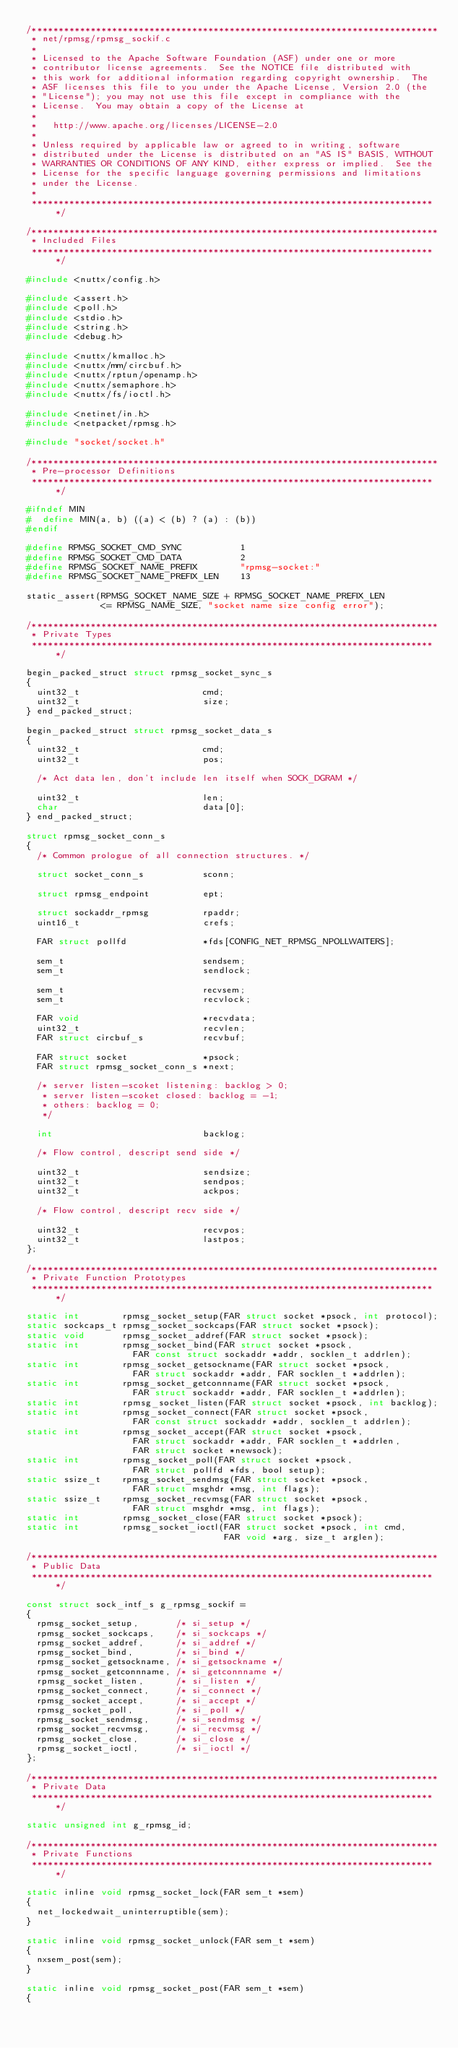Convert code to text. <code><loc_0><loc_0><loc_500><loc_500><_C_>/****************************************************************************
 * net/rpmsg/rpmsg_sockif.c
 *
 * Licensed to the Apache Software Foundation (ASF) under one or more
 * contributor license agreements.  See the NOTICE file distributed with
 * this work for additional information regarding copyright ownership.  The
 * ASF licenses this file to you under the Apache License, Version 2.0 (the
 * "License"); you may not use this file except in compliance with the
 * License.  You may obtain a copy of the License at
 *
 *   http://www.apache.org/licenses/LICENSE-2.0
 *
 * Unless required by applicable law or agreed to in writing, software
 * distributed under the License is distributed on an "AS IS" BASIS, WITHOUT
 * WARRANTIES OR CONDITIONS OF ANY KIND, either express or implied.  See the
 * License for the specific language governing permissions and limitations
 * under the License.
 *
 ****************************************************************************/

/****************************************************************************
 * Included Files
 ****************************************************************************/

#include <nuttx/config.h>

#include <assert.h>
#include <poll.h>
#include <stdio.h>
#include <string.h>
#include <debug.h>

#include <nuttx/kmalloc.h>
#include <nuttx/mm/circbuf.h>
#include <nuttx/rptun/openamp.h>
#include <nuttx/semaphore.h>
#include <nuttx/fs/ioctl.h>

#include <netinet/in.h>
#include <netpacket/rpmsg.h>

#include "socket/socket.h"

/****************************************************************************
 * Pre-processor Definitions
 ****************************************************************************/

#ifndef MIN
#  define MIN(a, b) ((a) < (b) ? (a) : (b))
#endif

#define RPMSG_SOCKET_CMD_SYNC           1
#define RPMSG_SOCKET_CMD_DATA           2
#define RPMSG_SOCKET_NAME_PREFIX        "rpmsg-socket:"
#define RPMSG_SOCKET_NAME_PREFIX_LEN    13

static_assert(RPMSG_SOCKET_NAME_SIZE + RPMSG_SOCKET_NAME_PREFIX_LEN
              <= RPMSG_NAME_SIZE, "socket name size config error");

/****************************************************************************
 * Private Types
 ****************************************************************************/

begin_packed_struct struct rpmsg_socket_sync_s
{
  uint32_t                       cmd;
  uint32_t                       size;
} end_packed_struct;

begin_packed_struct struct rpmsg_socket_data_s
{
  uint32_t                       cmd;
  uint32_t                       pos;

  /* Act data len, don't include len itself when SOCK_DGRAM */

  uint32_t                       len;
  char                           data[0];
} end_packed_struct;

struct rpmsg_socket_conn_s
{
  /* Common prologue of all connection structures. */

  struct socket_conn_s           sconn;

  struct rpmsg_endpoint          ept;

  struct sockaddr_rpmsg          rpaddr;
  uint16_t                       crefs;

  FAR struct pollfd              *fds[CONFIG_NET_RPMSG_NPOLLWAITERS];

  sem_t                          sendsem;
  sem_t                          sendlock;

  sem_t                          recvsem;
  sem_t                          recvlock;

  FAR void                       *recvdata;
  uint32_t                       recvlen;
  FAR struct circbuf_s           recvbuf;

  FAR struct socket              *psock;
  FAR struct rpmsg_socket_conn_s *next;

  /* server listen-scoket listening: backlog > 0;
   * server listen-scoket closed: backlog = -1;
   * others: backlog = 0;
   */

  int                            backlog;

  /* Flow control, descript send side */

  uint32_t                       sendsize;
  uint32_t                       sendpos;
  uint32_t                       ackpos;

  /* Flow control, descript recv side */

  uint32_t                       recvpos;
  uint32_t                       lastpos;
};

/****************************************************************************
 * Private Function Prototypes
 ****************************************************************************/

static int        rpmsg_socket_setup(FAR struct socket *psock, int protocol);
static sockcaps_t rpmsg_socket_sockcaps(FAR struct socket *psock);
static void       rpmsg_socket_addref(FAR struct socket *psock);
static int        rpmsg_socket_bind(FAR struct socket *psock,
                    FAR const struct sockaddr *addr, socklen_t addrlen);
static int        rpmsg_socket_getsockname(FAR struct socket *psock,
                    FAR struct sockaddr *addr, FAR socklen_t *addrlen);
static int        rpmsg_socket_getconnname(FAR struct socket *psock,
                    FAR struct sockaddr *addr, FAR socklen_t *addrlen);
static int        rpmsg_socket_listen(FAR struct socket *psock, int backlog);
static int        rpmsg_socket_connect(FAR struct socket *psock,
                    FAR const struct sockaddr *addr, socklen_t addrlen);
static int        rpmsg_socket_accept(FAR struct socket *psock,
                    FAR struct sockaddr *addr, FAR socklen_t *addrlen,
                    FAR struct socket *newsock);
static int        rpmsg_socket_poll(FAR struct socket *psock,
                    FAR struct pollfd *fds, bool setup);
static ssize_t    rpmsg_socket_sendmsg(FAR struct socket *psock,
                    FAR struct msghdr *msg, int flags);
static ssize_t    rpmsg_socket_recvmsg(FAR struct socket *psock,
                    FAR struct msghdr *msg, int flags);
static int        rpmsg_socket_close(FAR struct socket *psock);
static int        rpmsg_socket_ioctl(FAR struct socket *psock, int cmd,
                                     FAR void *arg, size_t arglen);

/****************************************************************************
 * Public Data
 ****************************************************************************/

const struct sock_intf_s g_rpmsg_sockif =
{
  rpmsg_socket_setup,       /* si_setup */
  rpmsg_socket_sockcaps,    /* si_sockcaps */
  rpmsg_socket_addref,      /* si_addref */
  rpmsg_socket_bind,        /* si_bind */
  rpmsg_socket_getsockname, /* si_getsockname */
  rpmsg_socket_getconnname, /* si_getconnname */
  rpmsg_socket_listen,      /* si_listen */
  rpmsg_socket_connect,     /* si_connect */
  rpmsg_socket_accept,      /* si_accept */
  rpmsg_socket_poll,        /* si_poll */
  rpmsg_socket_sendmsg,     /* si_sendmsg */
  rpmsg_socket_recvmsg,     /* si_recvmsg */
  rpmsg_socket_close,       /* si_close */
  rpmsg_socket_ioctl,       /* si_ioctl */
};

/****************************************************************************
 * Private Data
 ****************************************************************************/

static unsigned int g_rpmsg_id;

/****************************************************************************
 * Private Functions
 ****************************************************************************/

static inline void rpmsg_socket_lock(FAR sem_t *sem)
{
  net_lockedwait_uninterruptible(sem);
}

static inline void rpmsg_socket_unlock(FAR sem_t *sem)
{
  nxsem_post(sem);
}

static inline void rpmsg_socket_post(FAR sem_t *sem)
{</code> 